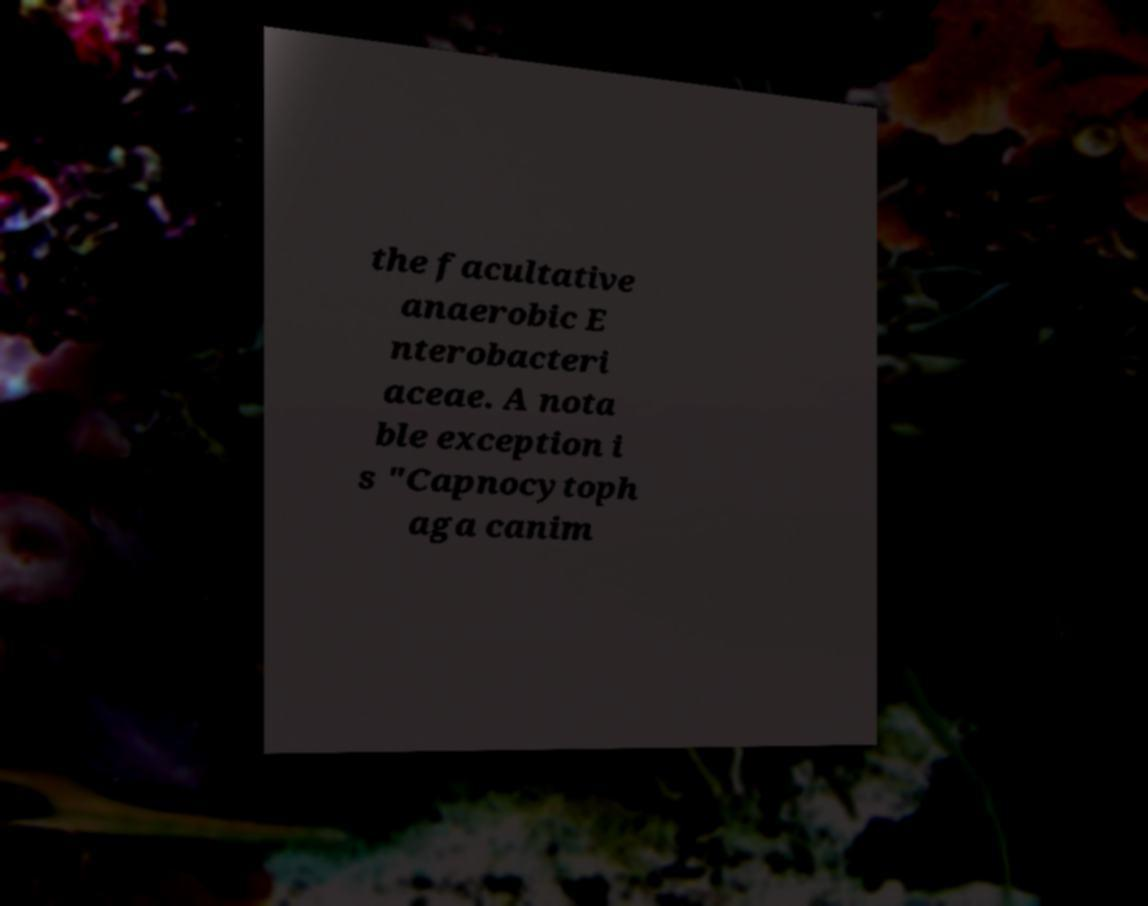Please identify and transcribe the text found in this image. the facultative anaerobic E nterobacteri aceae. A nota ble exception i s "Capnocytoph aga canim 